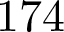<formula> <loc_0><loc_0><loc_500><loc_500>1 7 4</formula> 